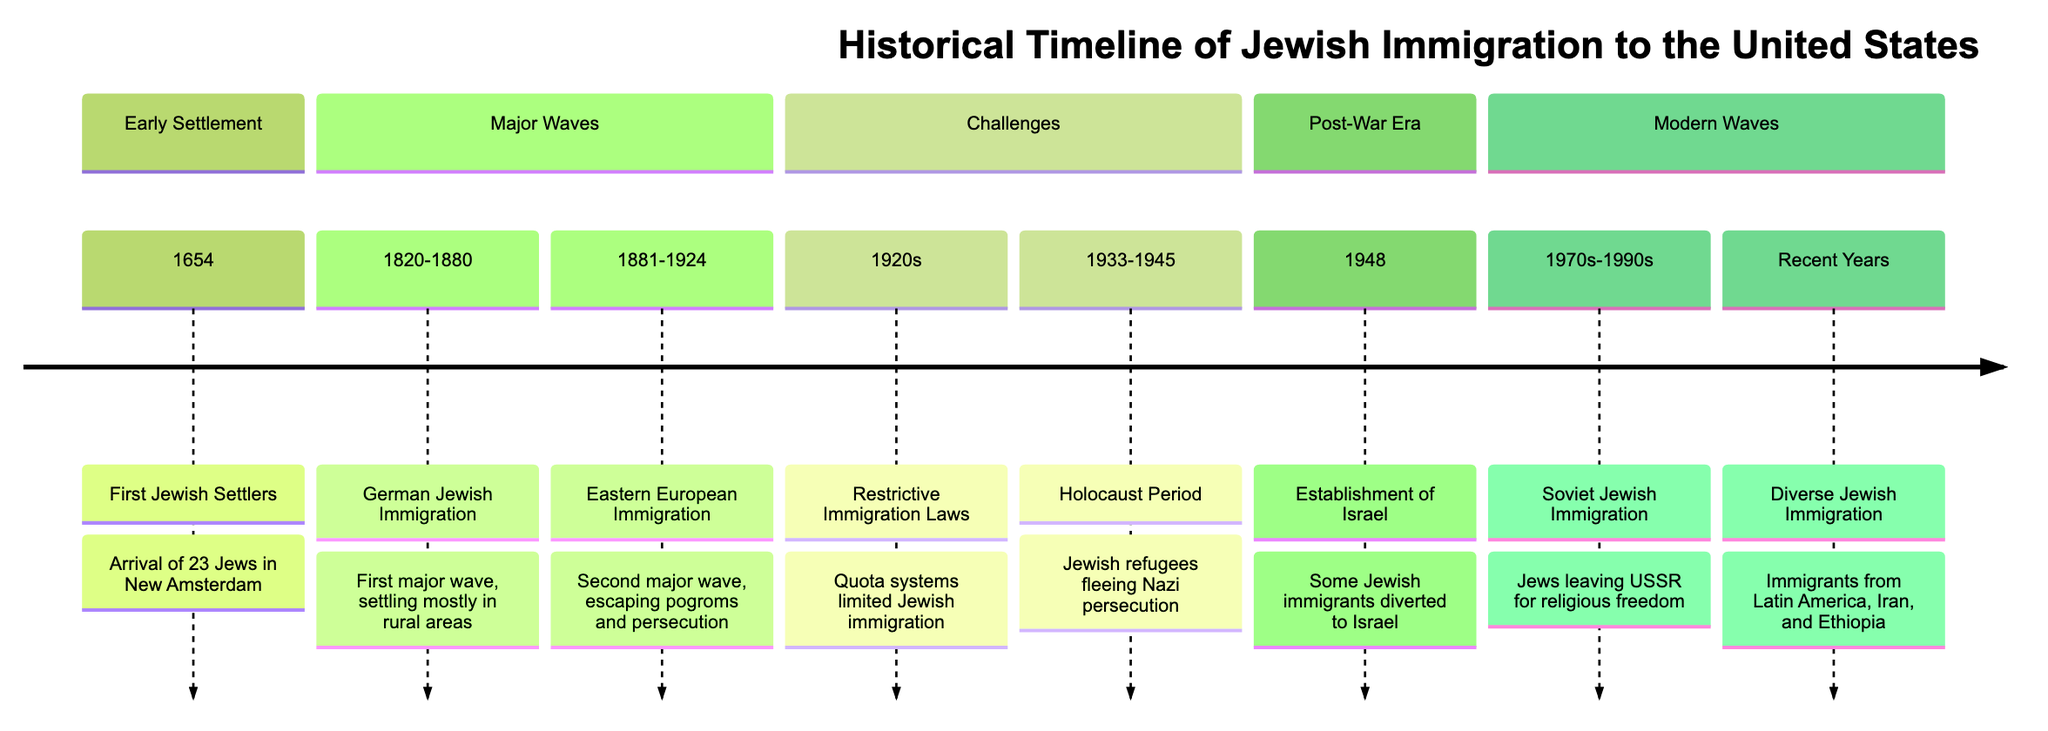What year did the first Jewish settlers arrive in New Amsterdam? The diagram indicates that the first Jewish settlers arrived in New Amsterdam in 1654. Therefore, the answer is directly found in the timeline of early settlement.
Answer: 1654 How many major waves of Jewish immigration are highlighted in the diagram? The diagram lists three major waves of Jewish immigration, which are the German Jewish Immigration (1820-1880), Eastern European Immigration (1881-1924), and Soviet Jewish Immigration (1970s-1990s). Counting these gives a total of three major waves.
Answer: 3 What event is associated with the year 1948? In the timeline, the year 1948 is associated with the establishment of Israel, indicating a significant event within the post-war era of Jewish immigration history.
Answer: Establishment of Israel What was a major reason for the Second wave of Jewish Immigration (1881-1924)? According to the diagram, the Second wave of Jewish Immigration was primarily driven by escaping pogroms and persecution, clearly highlighting the significant challenges faced by Jewish communities in Eastern Europe during that time.
Answer: Escaping pogroms and persecution What restrictive policy was enacted in the 1920s? The diagram specifies that the 1920s saw the introduction of restrictive immigration laws, particularly quota systems that limited Jewish immigration to the United States. This directly reflects the challenges faced by Jewish immigrants during this period.
Answer: Restrictive immigration laws Which period is marked by the Holocaust in the diagram? The diagram indicates the Holocaust period ranging from 1933 to 1945, outlining a critical and tragic time for Jewish refugees fleeing Nazi persecution. This span of years captures the intensity of the Jewish immigration experience during the Holocaust.
Answer: 1933-1945 Which immigrant groups have recently moved to the United States as per the diagram? The diagram notes that recent years have seen diverse Jewish immigration from various regions, specifically mentioning immigrants from Latin America, Iran, and Ethiopia, highlighting the ongoing changes in Jewish immigration trends.
Answer: Latin America, Iran, Ethiopia What theme is represented in the section Modern Waves? The Modern Waves section illustrates the patterns of Jewish immigration from the 1970s to 1990s, focusing on Soviet Jewish immigration, which was motivated by the desire for religious freedom. This reflects a theme of continued pursuit of liberty and community for Jewish people.
Answer: Soviet Jewish Immigration 